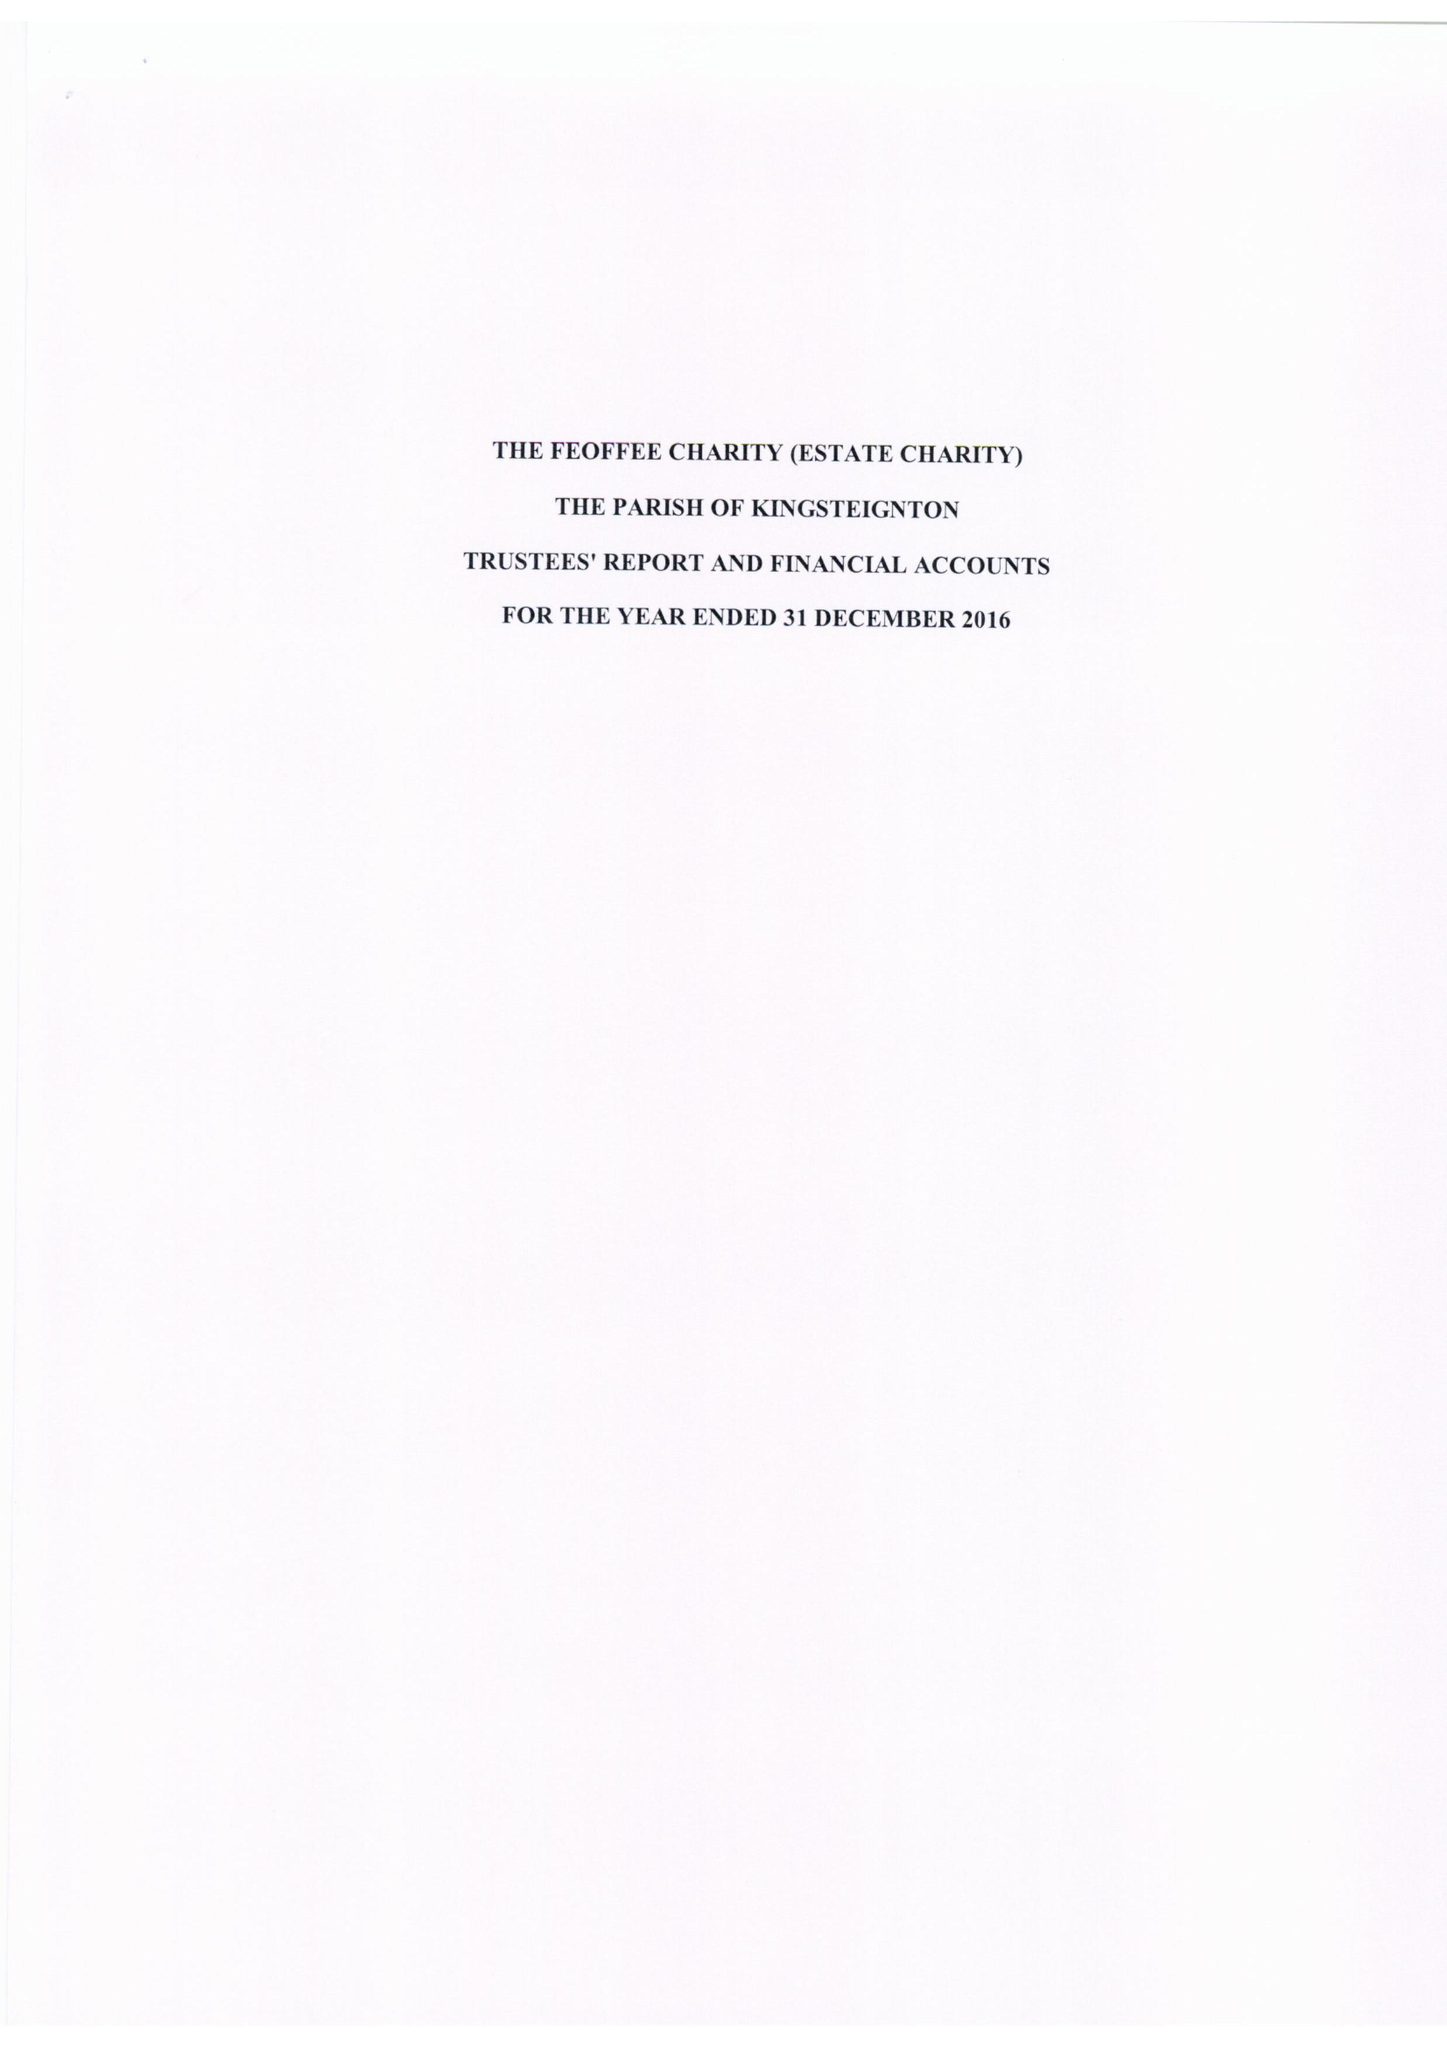What is the value for the charity_number?
Answer the question using a single word or phrase. 265541 